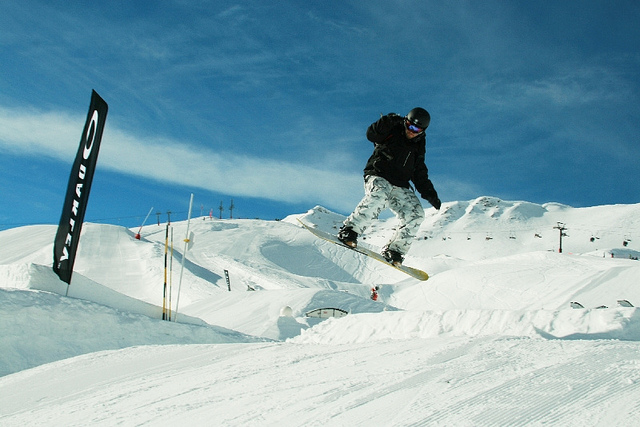Read all the text in this image. GUAHREA 